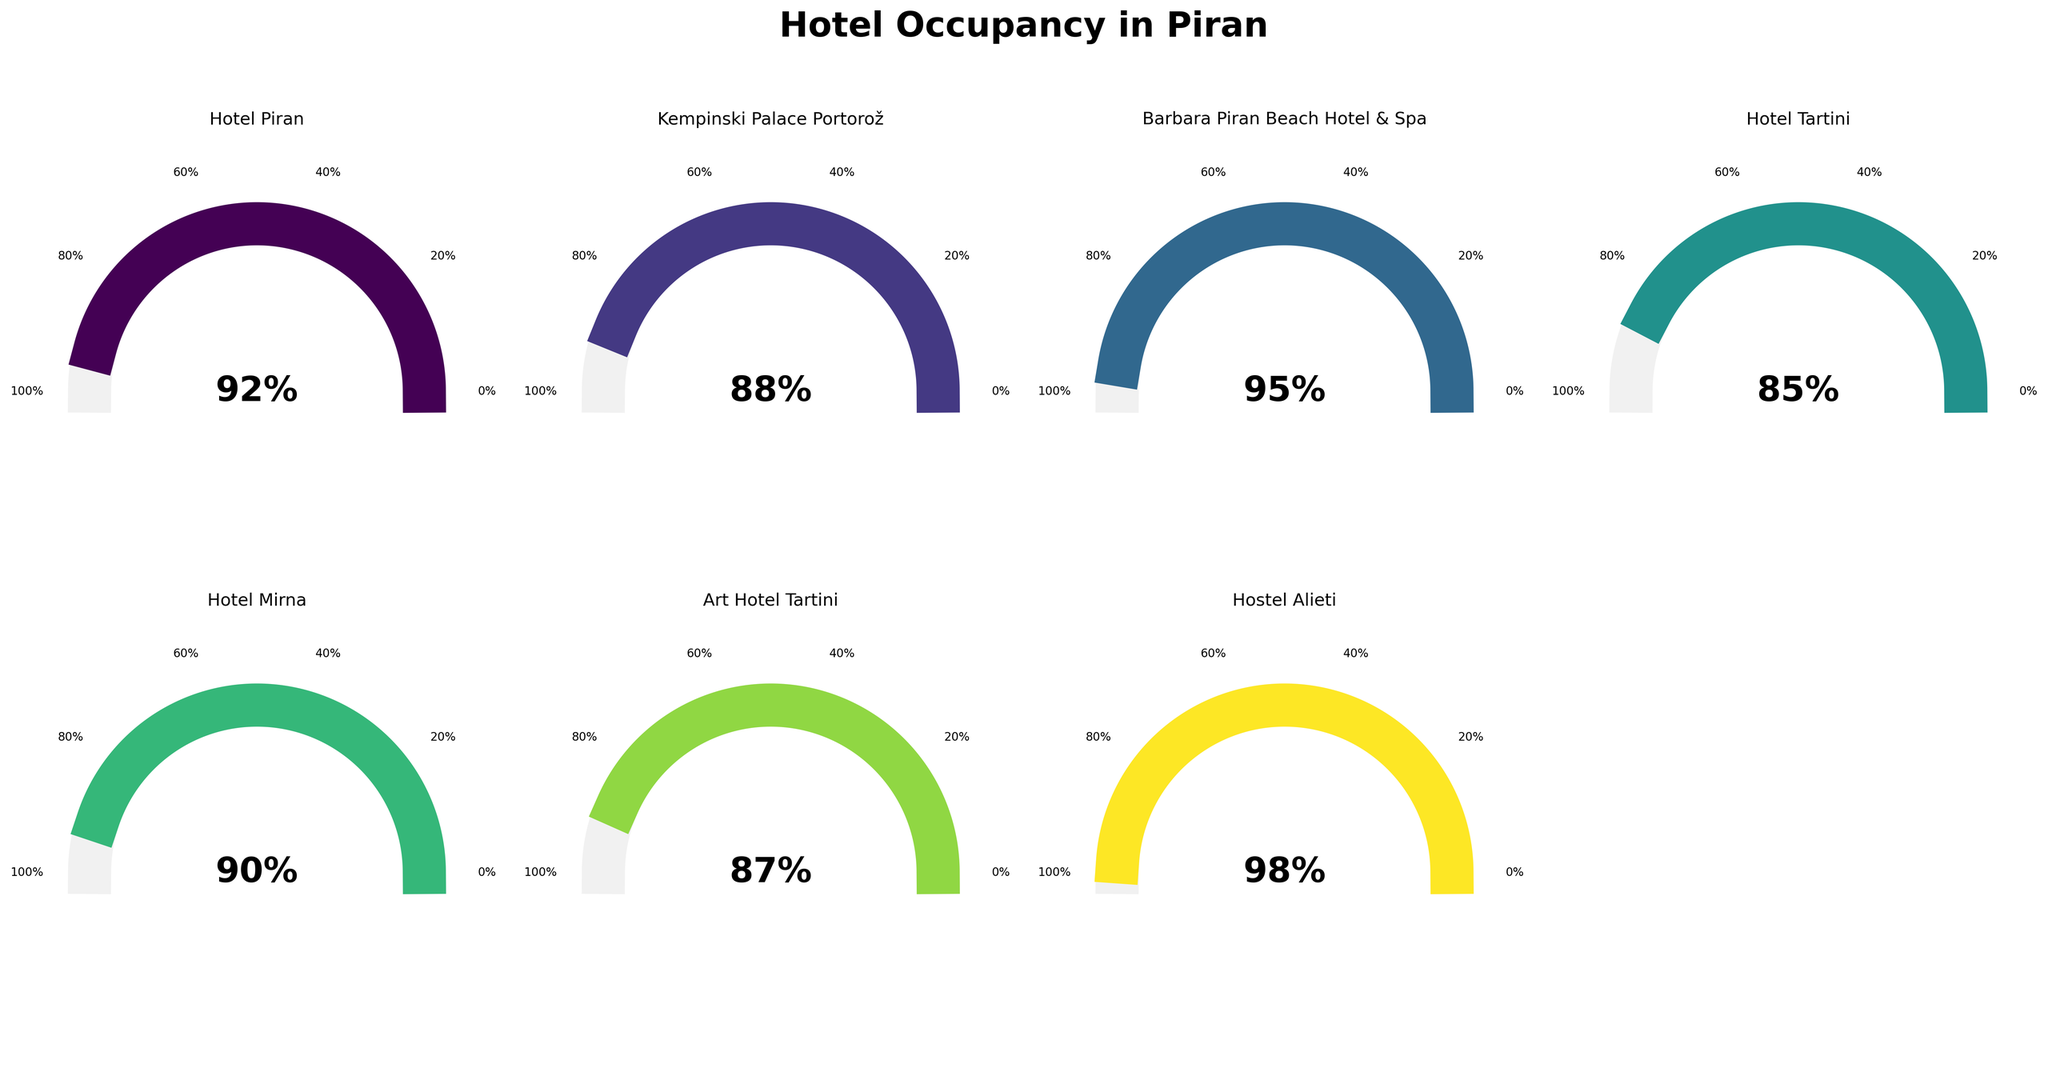What is the hotel with the highest occupancy percentage? Start by identifying the occupancy percentages of all hotels in the figure. The highest percentage visible is 98% for Hostel Alieti.
Answer: Hostel Alieti Which hotel has the lowest occupancy percentage? Look through the figure to find the hotel with the smallest percentage. Hotel Tartini has the lowest percentage at 85%.
Answer: Hotel Tartini What is the average occupancy percentage across all hotels? Calculate the total occupancy percentage: (92 + 88 + 95 + 85 + 90 + 87 + 98) = 635 and divide by the number of hotels (7). The average is 635 / 7 ≈ 90.7%.
Answer: 90.7% How many hotels have an occupancy rate above 90%? Count hotels with an occupancy percentage greater than 90. These are Hotel Piran (92%), Barbara Piran Beach Hotel & Spa (95%), and Hostel Alieti (98%). There are 3 such hotels.
Answer: 3 What is the combined occupancy percentage of Hotel Piran and Kempinski Palace Portorož? Sum their occupancy percentages: Hotel Piran (92%) + Kempinski Palace Portorož (88%) = 180%.
Answer: 180% Which two hotels have the closest occupancy percentages? Compare differences between each pair of hotels. Kempinski Palace Portorož (88%) and Art Hotel Tartini (87%) have a difference of only 1%.
Answer: Kempinski Palace Portorož and Art Hotel Tartini If you were to recommend a hotel with over 90% occupancy but not the highest, which would it be? Among hotels with over 90% occupancy, exclude Hostel Alieti (98%). The options are Hotel Piran (92%) and Barbara Piran Beach Hotel & Spa (95%). Either can be recommended.
Answer: Hotel Piran or Barbara Piran Beach Hotel & Spa What is the median occupancy percentage among the hotels? Arrange the occupancy percentages in order: 85, 87, 88, 90, 92, 95, 98. The median (middle value) is 90%.
Answer: 90% Calculate the difference in occupancy percentage between the hotel with the highest and the lowest rate. Subtract the lowest occupancy percentage (Hotel Tartini, 85%) from the highest (Hostel Alieti, 98%): 98% - 85% = 13%.
Answer: 13% Which hotel is closest to having an 88% occupancy rate? Find occupancies closest to 88%. Kempinski Palace Portorož has exactly 88%, so no other hotel is closer.
Answer: Kempinski Palace Portorož 